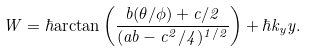Convert formula to latex. <formula><loc_0><loc_0><loc_500><loc_500>W = \hbar { \arctan } \left ( \frac { b ( \theta / \phi ) + c / 2 } { ( a b - c ^ { 2 } / 4 ) ^ { 1 / 2 } } \right ) + \hbar { k } _ { y } y .</formula> 